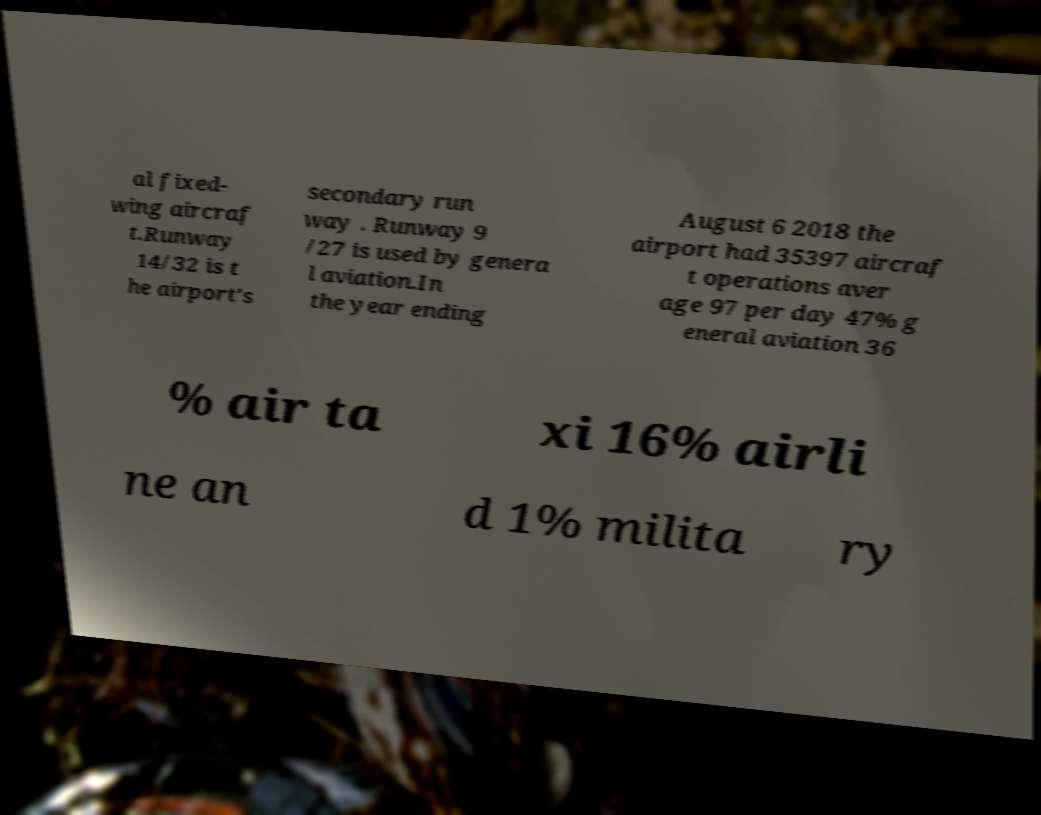Please identify and transcribe the text found in this image. al fixed- wing aircraf t.Runway 14/32 is t he airport's secondary run way . Runway 9 /27 is used by genera l aviation.In the year ending August 6 2018 the airport had 35397 aircraf t operations aver age 97 per day 47% g eneral aviation 36 % air ta xi 16% airli ne an d 1% milita ry 